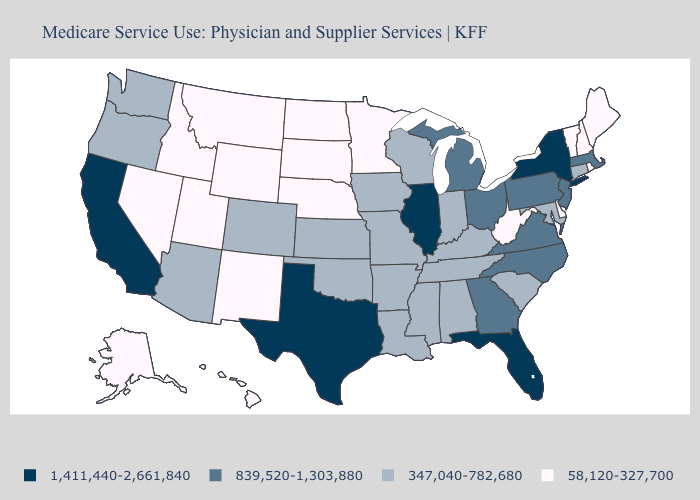Name the states that have a value in the range 839,520-1,303,880?
Short answer required. Georgia, Massachusetts, Michigan, New Jersey, North Carolina, Ohio, Pennsylvania, Virginia. What is the value of Alabama?
Write a very short answer. 347,040-782,680. Which states have the highest value in the USA?
Keep it brief. California, Florida, Illinois, New York, Texas. Name the states that have a value in the range 58,120-327,700?
Write a very short answer. Alaska, Delaware, Hawaii, Idaho, Maine, Minnesota, Montana, Nebraska, Nevada, New Hampshire, New Mexico, North Dakota, Rhode Island, South Dakota, Utah, Vermont, West Virginia, Wyoming. Does Oklahoma have the highest value in the South?
Quick response, please. No. Name the states that have a value in the range 1,411,440-2,661,840?
Quick response, please. California, Florida, Illinois, New York, Texas. What is the value of Nevada?
Give a very brief answer. 58,120-327,700. What is the value of Maryland?
Short answer required. 347,040-782,680. What is the value of Wisconsin?
Be succinct. 347,040-782,680. Does Indiana have the lowest value in the USA?
Be succinct. No. Which states hav the highest value in the MidWest?
Be succinct. Illinois. How many symbols are there in the legend?
Be succinct. 4. Among the states that border Nebraska , does Iowa have the highest value?
Concise answer only. Yes. What is the lowest value in states that border South Dakota?
Short answer required. 58,120-327,700. Among the states that border Oklahoma , does New Mexico have the lowest value?
Be succinct. Yes. 